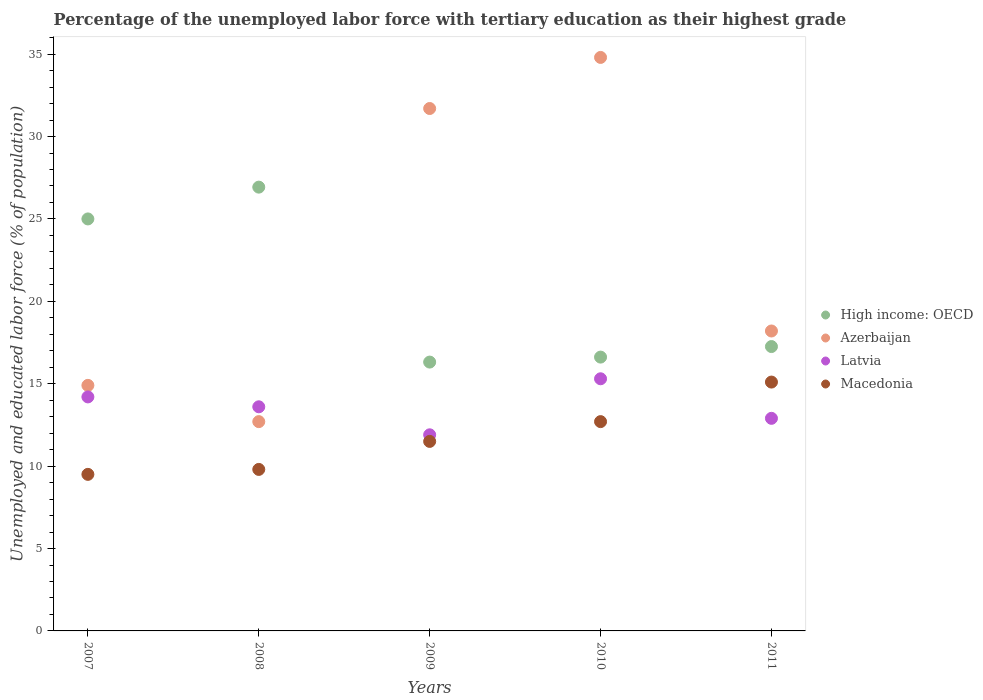Is the number of dotlines equal to the number of legend labels?
Your response must be concise. Yes. What is the percentage of the unemployed labor force with tertiary education in Latvia in 2010?
Keep it short and to the point. 15.3. Across all years, what is the maximum percentage of the unemployed labor force with tertiary education in Azerbaijan?
Provide a short and direct response. 34.8. Across all years, what is the minimum percentage of the unemployed labor force with tertiary education in Azerbaijan?
Offer a terse response. 12.7. In which year was the percentage of the unemployed labor force with tertiary education in Azerbaijan minimum?
Your answer should be very brief. 2008. What is the total percentage of the unemployed labor force with tertiary education in High income: OECD in the graph?
Ensure brevity in your answer.  102.11. What is the difference between the percentage of the unemployed labor force with tertiary education in Latvia in 2008 and that in 2010?
Provide a succinct answer. -1.7. What is the difference between the percentage of the unemployed labor force with tertiary education in High income: OECD in 2010 and the percentage of the unemployed labor force with tertiary education in Macedonia in 2008?
Keep it short and to the point. 6.82. What is the average percentage of the unemployed labor force with tertiary education in Macedonia per year?
Ensure brevity in your answer.  11.72. In the year 2007, what is the difference between the percentage of the unemployed labor force with tertiary education in Latvia and percentage of the unemployed labor force with tertiary education in High income: OECD?
Offer a very short reply. -10.8. In how many years, is the percentage of the unemployed labor force with tertiary education in High income: OECD greater than 31 %?
Offer a very short reply. 0. What is the ratio of the percentage of the unemployed labor force with tertiary education in Latvia in 2008 to that in 2010?
Ensure brevity in your answer.  0.89. What is the difference between the highest and the second highest percentage of the unemployed labor force with tertiary education in Latvia?
Offer a very short reply. 1.1. What is the difference between the highest and the lowest percentage of the unemployed labor force with tertiary education in Azerbaijan?
Your answer should be very brief. 22.1. In how many years, is the percentage of the unemployed labor force with tertiary education in Latvia greater than the average percentage of the unemployed labor force with tertiary education in Latvia taken over all years?
Provide a short and direct response. 3. Is the sum of the percentage of the unemployed labor force with tertiary education in Azerbaijan in 2007 and 2009 greater than the maximum percentage of the unemployed labor force with tertiary education in Macedonia across all years?
Offer a very short reply. Yes. Does the percentage of the unemployed labor force with tertiary education in High income: OECD monotonically increase over the years?
Keep it short and to the point. No. Is the percentage of the unemployed labor force with tertiary education in Latvia strictly greater than the percentage of the unemployed labor force with tertiary education in High income: OECD over the years?
Your answer should be very brief. No. How many dotlines are there?
Your answer should be compact. 4. How many years are there in the graph?
Your answer should be compact. 5. What is the difference between two consecutive major ticks on the Y-axis?
Offer a terse response. 5. Does the graph contain any zero values?
Give a very brief answer. No. Where does the legend appear in the graph?
Make the answer very short. Center right. How many legend labels are there?
Keep it short and to the point. 4. How are the legend labels stacked?
Ensure brevity in your answer.  Vertical. What is the title of the graph?
Provide a short and direct response. Percentage of the unemployed labor force with tertiary education as their highest grade. Does "Niger" appear as one of the legend labels in the graph?
Provide a succinct answer. No. What is the label or title of the X-axis?
Offer a very short reply. Years. What is the label or title of the Y-axis?
Provide a short and direct response. Unemployed and educated labor force (% of population). What is the Unemployed and educated labor force (% of population) in High income: OECD in 2007?
Your response must be concise. 25. What is the Unemployed and educated labor force (% of population) in Azerbaijan in 2007?
Keep it short and to the point. 14.9. What is the Unemployed and educated labor force (% of population) in Latvia in 2007?
Provide a short and direct response. 14.2. What is the Unemployed and educated labor force (% of population) of High income: OECD in 2008?
Your answer should be compact. 26.93. What is the Unemployed and educated labor force (% of population) in Azerbaijan in 2008?
Make the answer very short. 12.7. What is the Unemployed and educated labor force (% of population) in Latvia in 2008?
Your answer should be very brief. 13.6. What is the Unemployed and educated labor force (% of population) in Macedonia in 2008?
Your answer should be compact. 9.8. What is the Unemployed and educated labor force (% of population) in High income: OECD in 2009?
Provide a succinct answer. 16.31. What is the Unemployed and educated labor force (% of population) of Azerbaijan in 2009?
Your response must be concise. 31.7. What is the Unemployed and educated labor force (% of population) in Latvia in 2009?
Ensure brevity in your answer.  11.9. What is the Unemployed and educated labor force (% of population) of High income: OECD in 2010?
Give a very brief answer. 16.62. What is the Unemployed and educated labor force (% of population) in Azerbaijan in 2010?
Offer a very short reply. 34.8. What is the Unemployed and educated labor force (% of population) in Latvia in 2010?
Offer a very short reply. 15.3. What is the Unemployed and educated labor force (% of population) in Macedonia in 2010?
Your answer should be very brief. 12.7. What is the Unemployed and educated labor force (% of population) of High income: OECD in 2011?
Offer a terse response. 17.26. What is the Unemployed and educated labor force (% of population) in Azerbaijan in 2011?
Offer a very short reply. 18.2. What is the Unemployed and educated labor force (% of population) in Latvia in 2011?
Give a very brief answer. 12.9. What is the Unemployed and educated labor force (% of population) in Macedonia in 2011?
Your answer should be compact. 15.1. Across all years, what is the maximum Unemployed and educated labor force (% of population) in High income: OECD?
Give a very brief answer. 26.93. Across all years, what is the maximum Unemployed and educated labor force (% of population) in Azerbaijan?
Your answer should be compact. 34.8. Across all years, what is the maximum Unemployed and educated labor force (% of population) of Latvia?
Your response must be concise. 15.3. Across all years, what is the maximum Unemployed and educated labor force (% of population) in Macedonia?
Your response must be concise. 15.1. Across all years, what is the minimum Unemployed and educated labor force (% of population) in High income: OECD?
Make the answer very short. 16.31. Across all years, what is the minimum Unemployed and educated labor force (% of population) in Azerbaijan?
Offer a very short reply. 12.7. Across all years, what is the minimum Unemployed and educated labor force (% of population) in Latvia?
Ensure brevity in your answer.  11.9. Across all years, what is the minimum Unemployed and educated labor force (% of population) of Macedonia?
Your answer should be very brief. 9.5. What is the total Unemployed and educated labor force (% of population) in High income: OECD in the graph?
Give a very brief answer. 102.11. What is the total Unemployed and educated labor force (% of population) in Azerbaijan in the graph?
Give a very brief answer. 112.3. What is the total Unemployed and educated labor force (% of population) of Latvia in the graph?
Your response must be concise. 67.9. What is the total Unemployed and educated labor force (% of population) in Macedonia in the graph?
Make the answer very short. 58.6. What is the difference between the Unemployed and educated labor force (% of population) of High income: OECD in 2007 and that in 2008?
Ensure brevity in your answer.  -1.93. What is the difference between the Unemployed and educated labor force (% of population) in Macedonia in 2007 and that in 2008?
Your response must be concise. -0.3. What is the difference between the Unemployed and educated labor force (% of population) of High income: OECD in 2007 and that in 2009?
Offer a terse response. 8.69. What is the difference between the Unemployed and educated labor force (% of population) of Azerbaijan in 2007 and that in 2009?
Keep it short and to the point. -16.8. What is the difference between the Unemployed and educated labor force (% of population) of Macedonia in 2007 and that in 2009?
Keep it short and to the point. -2. What is the difference between the Unemployed and educated labor force (% of population) in High income: OECD in 2007 and that in 2010?
Give a very brief answer. 8.38. What is the difference between the Unemployed and educated labor force (% of population) in Azerbaijan in 2007 and that in 2010?
Give a very brief answer. -19.9. What is the difference between the Unemployed and educated labor force (% of population) of Macedonia in 2007 and that in 2010?
Offer a terse response. -3.2. What is the difference between the Unemployed and educated labor force (% of population) of High income: OECD in 2007 and that in 2011?
Give a very brief answer. 7.74. What is the difference between the Unemployed and educated labor force (% of population) in Macedonia in 2007 and that in 2011?
Ensure brevity in your answer.  -5.6. What is the difference between the Unemployed and educated labor force (% of population) in High income: OECD in 2008 and that in 2009?
Provide a short and direct response. 10.62. What is the difference between the Unemployed and educated labor force (% of population) in Azerbaijan in 2008 and that in 2009?
Give a very brief answer. -19. What is the difference between the Unemployed and educated labor force (% of population) in Latvia in 2008 and that in 2009?
Provide a short and direct response. 1.7. What is the difference between the Unemployed and educated labor force (% of population) in Macedonia in 2008 and that in 2009?
Your answer should be very brief. -1.7. What is the difference between the Unemployed and educated labor force (% of population) in High income: OECD in 2008 and that in 2010?
Offer a terse response. 10.31. What is the difference between the Unemployed and educated labor force (% of population) in Azerbaijan in 2008 and that in 2010?
Provide a succinct answer. -22.1. What is the difference between the Unemployed and educated labor force (% of population) of Latvia in 2008 and that in 2010?
Your answer should be very brief. -1.7. What is the difference between the Unemployed and educated labor force (% of population) of Macedonia in 2008 and that in 2010?
Keep it short and to the point. -2.9. What is the difference between the Unemployed and educated labor force (% of population) of High income: OECD in 2008 and that in 2011?
Provide a short and direct response. 9.67. What is the difference between the Unemployed and educated labor force (% of population) in Azerbaijan in 2008 and that in 2011?
Your response must be concise. -5.5. What is the difference between the Unemployed and educated labor force (% of population) in Latvia in 2008 and that in 2011?
Provide a short and direct response. 0.7. What is the difference between the Unemployed and educated labor force (% of population) in High income: OECD in 2009 and that in 2010?
Your answer should be very brief. -0.3. What is the difference between the Unemployed and educated labor force (% of population) in Macedonia in 2009 and that in 2010?
Your response must be concise. -1.2. What is the difference between the Unemployed and educated labor force (% of population) of High income: OECD in 2009 and that in 2011?
Provide a short and direct response. -0.94. What is the difference between the Unemployed and educated labor force (% of population) of High income: OECD in 2010 and that in 2011?
Keep it short and to the point. -0.64. What is the difference between the Unemployed and educated labor force (% of population) of Azerbaijan in 2010 and that in 2011?
Keep it short and to the point. 16.6. What is the difference between the Unemployed and educated labor force (% of population) in Macedonia in 2010 and that in 2011?
Give a very brief answer. -2.4. What is the difference between the Unemployed and educated labor force (% of population) in High income: OECD in 2007 and the Unemployed and educated labor force (% of population) in Azerbaijan in 2008?
Your answer should be very brief. 12.3. What is the difference between the Unemployed and educated labor force (% of population) in High income: OECD in 2007 and the Unemployed and educated labor force (% of population) in Latvia in 2008?
Ensure brevity in your answer.  11.4. What is the difference between the Unemployed and educated labor force (% of population) of High income: OECD in 2007 and the Unemployed and educated labor force (% of population) of Macedonia in 2008?
Provide a succinct answer. 15.2. What is the difference between the Unemployed and educated labor force (% of population) in Azerbaijan in 2007 and the Unemployed and educated labor force (% of population) in Latvia in 2008?
Your response must be concise. 1.3. What is the difference between the Unemployed and educated labor force (% of population) of Latvia in 2007 and the Unemployed and educated labor force (% of population) of Macedonia in 2008?
Give a very brief answer. 4.4. What is the difference between the Unemployed and educated labor force (% of population) in High income: OECD in 2007 and the Unemployed and educated labor force (% of population) in Azerbaijan in 2009?
Provide a short and direct response. -6.7. What is the difference between the Unemployed and educated labor force (% of population) of High income: OECD in 2007 and the Unemployed and educated labor force (% of population) of Latvia in 2009?
Your answer should be very brief. 13.1. What is the difference between the Unemployed and educated labor force (% of population) of High income: OECD in 2007 and the Unemployed and educated labor force (% of population) of Macedonia in 2009?
Ensure brevity in your answer.  13.5. What is the difference between the Unemployed and educated labor force (% of population) of Azerbaijan in 2007 and the Unemployed and educated labor force (% of population) of Latvia in 2009?
Ensure brevity in your answer.  3. What is the difference between the Unemployed and educated labor force (% of population) of Azerbaijan in 2007 and the Unemployed and educated labor force (% of population) of Macedonia in 2009?
Keep it short and to the point. 3.4. What is the difference between the Unemployed and educated labor force (% of population) of Latvia in 2007 and the Unemployed and educated labor force (% of population) of Macedonia in 2009?
Your response must be concise. 2.7. What is the difference between the Unemployed and educated labor force (% of population) in High income: OECD in 2007 and the Unemployed and educated labor force (% of population) in Azerbaijan in 2010?
Offer a very short reply. -9.8. What is the difference between the Unemployed and educated labor force (% of population) in High income: OECD in 2007 and the Unemployed and educated labor force (% of population) in Latvia in 2010?
Provide a succinct answer. 9.7. What is the difference between the Unemployed and educated labor force (% of population) of High income: OECD in 2007 and the Unemployed and educated labor force (% of population) of Macedonia in 2010?
Provide a succinct answer. 12.3. What is the difference between the Unemployed and educated labor force (% of population) in Latvia in 2007 and the Unemployed and educated labor force (% of population) in Macedonia in 2010?
Your answer should be compact. 1.5. What is the difference between the Unemployed and educated labor force (% of population) of High income: OECD in 2007 and the Unemployed and educated labor force (% of population) of Azerbaijan in 2011?
Your answer should be very brief. 6.8. What is the difference between the Unemployed and educated labor force (% of population) in High income: OECD in 2007 and the Unemployed and educated labor force (% of population) in Latvia in 2011?
Keep it short and to the point. 12.1. What is the difference between the Unemployed and educated labor force (% of population) of High income: OECD in 2007 and the Unemployed and educated labor force (% of population) of Macedonia in 2011?
Make the answer very short. 9.9. What is the difference between the Unemployed and educated labor force (% of population) in Azerbaijan in 2007 and the Unemployed and educated labor force (% of population) in Macedonia in 2011?
Offer a terse response. -0.2. What is the difference between the Unemployed and educated labor force (% of population) of High income: OECD in 2008 and the Unemployed and educated labor force (% of population) of Azerbaijan in 2009?
Provide a succinct answer. -4.77. What is the difference between the Unemployed and educated labor force (% of population) in High income: OECD in 2008 and the Unemployed and educated labor force (% of population) in Latvia in 2009?
Make the answer very short. 15.03. What is the difference between the Unemployed and educated labor force (% of population) of High income: OECD in 2008 and the Unemployed and educated labor force (% of population) of Macedonia in 2009?
Make the answer very short. 15.43. What is the difference between the Unemployed and educated labor force (% of population) in Azerbaijan in 2008 and the Unemployed and educated labor force (% of population) in Latvia in 2009?
Offer a terse response. 0.8. What is the difference between the Unemployed and educated labor force (% of population) in Latvia in 2008 and the Unemployed and educated labor force (% of population) in Macedonia in 2009?
Offer a very short reply. 2.1. What is the difference between the Unemployed and educated labor force (% of population) of High income: OECD in 2008 and the Unemployed and educated labor force (% of population) of Azerbaijan in 2010?
Your answer should be compact. -7.87. What is the difference between the Unemployed and educated labor force (% of population) in High income: OECD in 2008 and the Unemployed and educated labor force (% of population) in Latvia in 2010?
Your answer should be compact. 11.63. What is the difference between the Unemployed and educated labor force (% of population) in High income: OECD in 2008 and the Unemployed and educated labor force (% of population) in Macedonia in 2010?
Provide a succinct answer. 14.23. What is the difference between the Unemployed and educated labor force (% of population) of Azerbaijan in 2008 and the Unemployed and educated labor force (% of population) of Macedonia in 2010?
Provide a succinct answer. 0. What is the difference between the Unemployed and educated labor force (% of population) in Latvia in 2008 and the Unemployed and educated labor force (% of population) in Macedonia in 2010?
Your response must be concise. 0.9. What is the difference between the Unemployed and educated labor force (% of population) of High income: OECD in 2008 and the Unemployed and educated labor force (% of population) of Azerbaijan in 2011?
Your answer should be compact. 8.73. What is the difference between the Unemployed and educated labor force (% of population) in High income: OECD in 2008 and the Unemployed and educated labor force (% of population) in Latvia in 2011?
Offer a terse response. 14.03. What is the difference between the Unemployed and educated labor force (% of population) of High income: OECD in 2008 and the Unemployed and educated labor force (% of population) of Macedonia in 2011?
Your answer should be very brief. 11.83. What is the difference between the Unemployed and educated labor force (% of population) in Azerbaijan in 2008 and the Unemployed and educated labor force (% of population) in Latvia in 2011?
Offer a terse response. -0.2. What is the difference between the Unemployed and educated labor force (% of population) in Azerbaijan in 2008 and the Unemployed and educated labor force (% of population) in Macedonia in 2011?
Your answer should be compact. -2.4. What is the difference between the Unemployed and educated labor force (% of population) of High income: OECD in 2009 and the Unemployed and educated labor force (% of population) of Azerbaijan in 2010?
Ensure brevity in your answer.  -18.49. What is the difference between the Unemployed and educated labor force (% of population) in High income: OECD in 2009 and the Unemployed and educated labor force (% of population) in Latvia in 2010?
Provide a succinct answer. 1.01. What is the difference between the Unemployed and educated labor force (% of population) in High income: OECD in 2009 and the Unemployed and educated labor force (% of population) in Macedonia in 2010?
Keep it short and to the point. 3.61. What is the difference between the Unemployed and educated labor force (% of population) in Azerbaijan in 2009 and the Unemployed and educated labor force (% of population) in Latvia in 2010?
Your answer should be compact. 16.4. What is the difference between the Unemployed and educated labor force (% of population) in Azerbaijan in 2009 and the Unemployed and educated labor force (% of population) in Macedonia in 2010?
Your answer should be very brief. 19. What is the difference between the Unemployed and educated labor force (% of population) in Latvia in 2009 and the Unemployed and educated labor force (% of population) in Macedonia in 2010?
Your response must be concise. -0.8. What is the difference between the Unemployed and educated labor force (% of population) in High income: OECD in 2009 and the Unemployed and educated labor force (% of population) in Azerbaijan in 2011?
Provide a succinct answer. -1.89. What is the difference between the Unemployed and educated labor force (% of population) in High income: OECD in 2009 and the Unemployed and educated labor force (% of population) in Latvia in 2011?
Your response must be concise. 3.41. What is the difference between the Unemployed and educated labor force (% of population) of High income: OECD in 2009 and the Unemployed and educated labor force (% of population) of Macedonia in 2011?
Your response must be concise. 1.21. What is the difference between the Unemployed and educated labor force (% of population) of Azerbaijan in 2009 and the Unemployed and educated labor force (% of population) of Latvia in 2011?
Make the answer very short. 18.8. What is the difference between the Unemployed and educated labor force (% of population) in Azerbaijan in 2009 and the Unemployed and educated labor force (% of population) in Macedonia in 2011?
Keep it short and to the point. 16.6. What is the difference between the Unemployed and educated labor force (% of population) of Latvia in 2009 and the Unemployed and educated labor force (% of population) of Macedonia in 2011?
Provide a succinct answer. -3.2. What is the difference between the Unemployed and educated labor force (% of population) in High income: OECD in 2010 and the Unemployed and educated labor force (% of population) in Azerbaijan in 2011?
Make the answer very short. -1.58. What is the difference between the Unemployed and educated labor force (% of population) in High income: OECD in 2010 and the Unemployed and educated labor force (% of population) in Latvia in 2011?
Keep it short and to the point. 3.72. What is the difference between the Unemployed and educated labor force (% of population) of High income: OECD in 2010 and the Unemployed and educated labor force (% of population) of Macedonia in 2011?
Keep it short and to the point. 1.52. What is the difference between the Unemployed and educated labor force (% of population) of Azerbaijan in 2010 and the Unemployed and educated labor force (% of population) of Latvia in 2011?
Offer a very short reply. 21.9. What is the difference between the Unemployed and educated labor force (% of population) in Azerbaijan in 2010 and the Unemployed and educated labor force (% of population) in Macedonia in 2011?
Your answer should be compact. 19.7. What is the difference between the Unemployed and educated labor force (% of population) in Latvia in 2010 and the Unemployed and educated labor force (% of population) in Macedonia in 2011?
Your response must be concise. 0.2. What is the average Unemployed and educated labor force (% of population) in High income: OECD per year?
Your answer should be very brief. 20.42. What is the average Unemployed and educated labor force (% of population) of Azerbaijan per year?
Your answer should be very brief. 22.46. What is the average Unemployed and educated labor force (% of population) in Latvia per year?
Provide a short and direct response. 13.58. What is the average Unemployed and educated labor force (% of population) in Macedonia per year?
Offer a terse response. 11.72. In the year 2007, what is the difference between the Unemployed and educated labor force (% of population) in High income: OECD and Unemployed and educated labor force (% of population) in Azerbaijan?
Make the answer very short. 10.1. In the year 2007, what is the difference between the Unemployed and educated labor force (% of population) of High income: OECD and Unemployed and educated labor force (% of population) of Latvia?
Your response must be concise. 10.8. In the year 2007, what is the difference between the Unemployed and educated labor force (% of population) of High income: OECD and Unemployed and educated labor force (% of population) of Macedonia?
Offer a terse response. 15.5. In the year 2007, what is the difference between the Unemployed and educated labor force (% of population) in Azerbaijan and Unemployed and educated labor force (% of population) in Macedonia?
Make the answer very short. 5.4. In the year 2007, what is the difference between the Unemployed and educated labor force (% of population) in Latvia and Unemployed and educated labor force (% of population) in Macedonia?
Provide a short and direct response. 4.7. In the year 2008, what is the difference between the Unemployed and educated labor force (% of population) of High income: OECD and Unemployed and educated labor force (% of population) of Azerbaijan?
Ensure brevity in your answer.  14.23. In the year 2008, what is the difference between the Unemployed and educated labor force (% of population) of High income: OECD and Unemployed and educated labor force (% of population) of Latvia?
Ensure brevity in your answer.  13.33. In the year 2008, what is the difference between the Unemployed and educated labor force (% of population) of High income: OECD and Unemployed and educated labor force (% of population) of Macedonia?
Ensure brevity in your answer.  17.13. In the year 2008, what is the difference between the Unemployed and educated labor force (% of population) in Azerbaijan and Unemployed and educated labor force (% of population) in Latvia?
Offer a terse response. -0.9. In the year 2008, what is the difference between the Unemployed and educated labor force (% of population) in Latvia and Unemployed and educated labor force (% of population) in Macedonia?
Offer a very short reply. 3.8. In the year 2009, what is the difference between the Unemployed and educated labor force (% of population) of High income: OECD and Unemployed and educated labor force (% of population) of Azerbaijan?
Offer a very short reply. -15.39. In the year 2009, what is the difference between the Unemployed and educated labor force (% of population) of High income: OECD and Unemployed and educated labor force (% of population) of Latvia?
Your answer should be very brief. 4.41. In the year 2009, what is the difference between the Unemployed and educated labor force (% of population) of High income: OECD and Unemployed and educated labor force (% of population) of Macedonia?
Provide a succinct answer. 4.81. In the year 2009, what is the difference between the Unemployed and educated labor force (% of population) of Azerbaijan and Unemployed and educated labor force (% of population) of Latvia?
Your answer should be very brief. 19.8. In the year 2009, what is the difference between the Unemployed and educated labor force (% of population) of Azerbaijan and Unemployed and educated labor force (% of population) of Macedonia?
Offer a terse response. 20.2. In the year 2010, what is the difference between the Unemployed and educated labor force (% of population) of High income: OECD and Unemployed and educated labor force (% of population) of Azerbaijan?
Offer a terse response. -18.18. In the year 2010, what is the difference between the Unemployed and educated labor force (% of population) in High income: OECD and Unemployed and educated labor force (% of population) in Latvia?
Make the answer very short. 1.32. In the year 2010, what is the difference between the Unemployed and educated labor force (% of population) of High income: OECD and Unemployed and educated labor force (% of population) of Macedonia?
Ensure brevity in your answer.  3.92. In the year 2010, what is the difference between the Unemployed and educated labor force (% of population) in Azerbaijan and Unemployed and educated labor force (% of population) in Macedonia?
Make the answer very short. 22.1. In the year 2011, what is the difference between the Unemployed and educated labor force (% of population) in High income: OECD and Unemployed and educated labor force (% of population) in Azerbaijan?
Your answer should be very brief. -0.94. In the year 2011, what is the difference between the Unemployed and educated labor force (% of population) of High income: OECD and Unemployed and educated labor force (% of population) of Latvia?
Your answer should be very brief. 4.36. In the year 2011, what is the difference between the Unemployed and educated labor force (% of population) of High income: OECD and Unemployed and educated labor force (% of population) of Macedonia?
Offer a very short reply. 2.16. In the year 2011, what is the difference between the Unemployed and educated labor force (% of population) in Azerbaijan and Unemployed and educated labor force (% of population) in Latvia?
Keep it short and to the point. 5.3. What is the ratio of the Unemployed and educated labor force (% of population) of High income: OECD in 2007 to that in 2008?
Provide a short and direct response. 0.93. What is the ratio of the Unemployed and educated labor force (% of population) of Azerbaijan in 2007 to that in 2008?
Keep it short and to the point. 1.17. What is the ratio of the Unemployed and educated labor force (% of population) in Latvia in 2007 to that in 2008?
Your answer should be very brief. 1.04. What is the ratio of the Unemployed and educated labor force (% of population) of Macedonia in 2007 to that in 2008?
Your answer should be compact. 0.97. What is the ratio of the Unemployed and educated labor force (% of population) of High income: OECD in 2007 to that in 2009?
Provide a short and direct response. 1.53. What is the ratio of the Unemployed and educated labor force (% of population) in Azerbaijan in 2007 to that in 2009?
Your answer should be very brief. 0.47. What is the ratio of the Unemployed and educated labor force (% of population) of Latvia in 2007 to that in 2009?
Offer a terse response. 1.19. What is the ratio of the Unemployed and educated labor force (% of population) in Macedonia in 2007 to that in 2009?
Offer a terse response. 0.83. What is the ratio of the Unemployed and educated labor force (% of population) of High income: OECD in 2007 to that in 2010?
Offer a very short reply. 1.5. What is the ratio of the Unemployed and educated labor force (% of population) of Azerbaijan in 2007 to that in 2010?
Your answer should be compact. 0.43. What is the ratio of the Unemployed and educated labor force (% of population) in Latvia in 2007 to that in 2010?
Keep it short and to the point. 0.93. What is the ratio of the Unemployed and educated labor force (% of population) in Macedonia in 2007 to that in 2010?
Provide a succinct answer. 0.75. What is the ratio of the Unemployed and educated labor force (% of population) of High income: OECD in 2007 to that in 2011?
Give a very brief answer. 1.45. What is the ratio of the Unemployed and educated labor force (% of population) of Azerbaijan in 2007 to that in 2011?
Your answer should be very brief. 0.82. What is the ratio of the Unemployed and educated labor force (% of population) of Latvia in 2007 to that in 2011?
Keep it short and to the point. 1.1. What is the ratio of the Unemployed and educated labor force (% of population) in Macedonia in 2007 to that in 2011?
Make the answer very short. 0.63. What is the ratio of the Unemployed and educated labor force (% of population) of High income: OECD in 2008 to that in 2009?
Your answer should be very brief. 1.65. What is the ratio of the Unemployed and educated labor force (% of population) in Azerbaijan in 2008 to that in 2009?
Offer a terse response. 0.4. What is the ratio of the Unemployed and educated labor force (% of population) of Macedonia in 2008 to that in 2009?
Your answer should be compact. 0.85. What is the ratio of the Unemployed and educated labor force (% of population) in High income: OECD in 2008 to that in 2010?
Your answer should be very brief. 1.62. What is the ratio of the Unemployed and educated labor force (% of population) in Azerbaijan in 2008 to that in 2010?
Make the answer very short. 0.36. What is the ratio of the Unemployed and educated labor force (% of population) of Latvia in 2008 to that in 2010?
Provide a succinct answer. 0.89. What is the ratio of the Unemployed and educated labor force (% of population) of Macedonia in 2008 to that in 2010?
Provide a succinct answer. 0.77. What is the ratio of the Unemployed and educated labor force (% of population) in High income: OECD in 2008 to that in 2011?
Ensure brevity in your answer.  1.56. What is the ratio of the Unemployed and educated labor force (% of population) of Azerbaijan in 2008 to that in 2011?
Offer a very short reply. 0.7. What is the ratio of the Unemployed and educated labor force (% of population) in Latvia in 2008 to that in 2011?
Your answer should be very brief. 1.05. What is the ratio of the Unemployed and educated labor force (% of population) in Macedonia in 2008 to that in 2011?
Keep it short and to the point. 0.65. What is the ratio of the Unemployed and educated labor force (% of population) in High income: OECD in 2009 to that in 2010?
Your answer should be very brief. 0.98. What is the ratio of the Unemployed and educated labor force (% of population) in Azerbaijan in 2009 to that in 2010?
Provide a succinct answer. 0.91. What is the ratio of the Unemployed and educated labor force (% of population) of Macedonia in 2009 to that in 2010?
Your answer should be very brief. 0.91. What is the ratio of the Unemployed and educated labor force (% of population) in High income: OECD in 2009 to that in 2011?
Your answer should be compact. 0.95. What is the ratio of the Unemployed and educated labor force (% of population) of Azerbaijan in 2009 to that in 2011?
Give a very brief answer. 1.74. What is the ratio of the Unemployed and educated labor force (% of population) in Latvia in 2009 to that in 2011?
Offer a terse response. 0.92. What is the ratio of the Unemployed and educated labor force (% of population) of Macedonia in 2009 to that in 2011?
Keep it short and to the point. 0.76. What is the ratio of the Unemployed and educated labor force (% of population) of High income: OECD in 2010 to that in 2011?
Make the answer very short. 0.96. What is the ratio of the Unemployed and educated labor force (% of population) in Azerbaijan in 2010 to that in 2011?
Ensure brevity in your answer.  1.91. What is the ratio of the Unemployed and educated labor force (% of population) of Latvia in 2010 to that in 2011?
Your answer should be compact. 1.19. What is the ratio of the Unemployed and educated labor force (% of population) in Macedonia in 2010 to that in 2011?
Keep it short and to the point. 0.84. What is the difference between the highest and the second highest Unemployed and educated labor force (% of population) of High income: OECD?
Make the answer very short. 1.93. What is the difference between the highest and the second highest Unemployed and educated labor force (% of population) in Azerbaijan?
Your answer should be very brief. 3.1. What is the difference between the highest and the lowest Unemployed and educated labor force (% of population) of High income: OECD?
Give a very brief answer. 10.62. What is the difference between the highest and the lowest Unemployed and educated labor force (% of population) in Azerbaijan?
Offer a terse response. 22.1. What is the difference between the highest and the lowest Unemployed and educated labor force (% of population) in Latvia?
Provide a succinct answer. 3.4. 